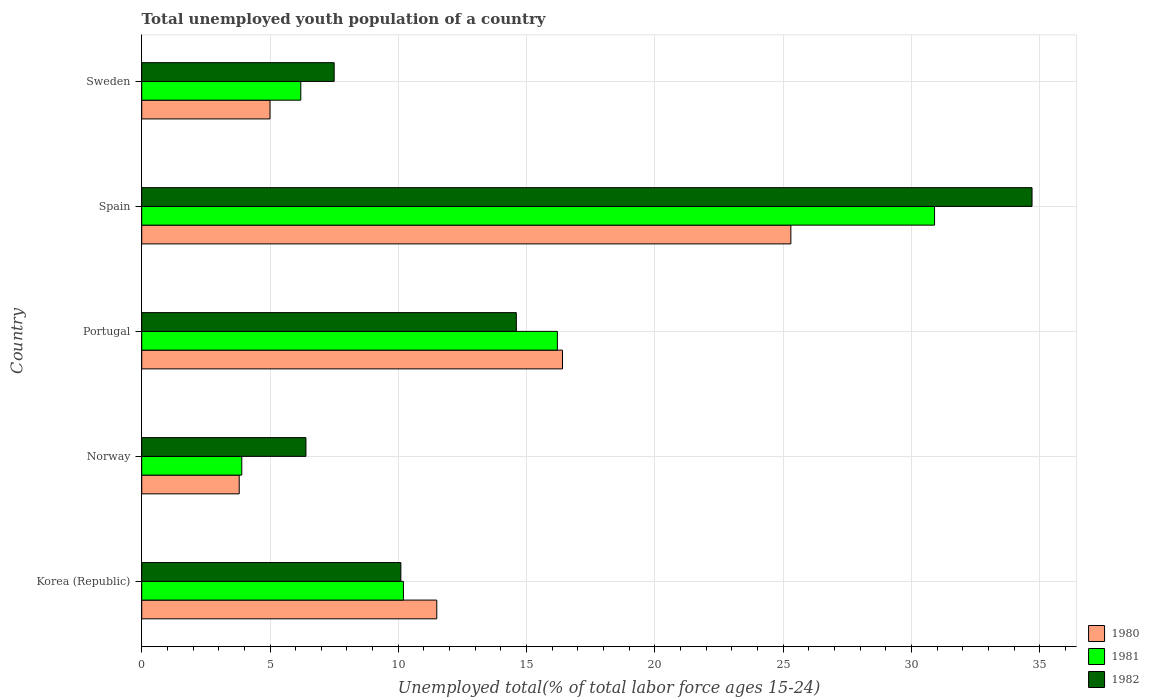How many different coloured bars are there?
Your answer should be compact. 3. Are the number of bars per tick equal to the number of legend labels?
Offer a very short reply. Yes. Are the number of bars on each tick of the Y-axis equal?
Your response must be concise. Yes. How many bars are there on the 5th tick from the top?
Your answer should be compact. 3. What is the label of the 5th group of bars from the top?
Provide a short and direct response. Korea (Republic). In how many cases, is the number of bars for a given country not equal to the number of legend labels?
Ensure brevity in your answer.  0. What is the percentage of total unemployed youth population of a country in 1980 in Norway?
Offer a terse response. 3.8. Across all countries, what is the maximum percentage of total unemployed youth population of a country in 1980?
Keep it short and to the point. 25.3. Across all countries, what is the minimum percentage of total unemployed youth population of a country in 1982?
Ensure brevity in your answer.  6.4. In which country was the percentage of total unemployed youth population of a country in 1980 maximum?
Keep it short and to the point. Spain. What is the total percentage of total unemployed youth population of a country in 1982 in the graph?
Keep it short and to the point. 73.3. What is the difference between the percentage of total unemployed youth population of a country in 1981 in Korea (Republic) and that in Sweden?
Your answer should be very brief. 4. What is the difference between the percentage of total unemployed youth population of a country in 1981 in Spain and the percentage of total unemployed youth population of a country in 1980 in Korea (Republic)?
Provide a succinct answer. 19.4. What is the average percentage of total unemployed youth population of a country in 1980 per country?
Offer a terse response. 12.4. What is the difference between the percentage of total unemployed youth population of a country in 1982 and percentage of total unemployed youth population of a country in 1981 in Spain?
Offer a very short reply. 3.8. In how many countries, is the percentage of total unemployed youth population of a country in 1981 greater than 23 %?
Keep it short and to the point. 1. What is the ratio of the percentage of total unemployed youth population of a country in 1980 in Norway to that in Sweden?
Provide a short and direct response. 0.76. Is the percentage of total unemployed youth population of a country in 1980 in Korea (Republic) less than that in Norway?
Your response must be concise. No. Is the difference between the percentage of total unemployed youth population of a country in 1982 in Portugal and Sweden greater than the difference between the percentage of total unemployed youth population of a country in 1981 in Portugal and Sweden?
Provide a short and direct response. No. What is the difference between the highest and the second highest percentage of total unemployed youth population of a country in 1981?
Your answer should be very brief. 14.7. What is the difference between the highest and the lowest percentage of total unemployed youth population of a country in 1981?
Provide a succinct answer. 27. In how many countries, is the percentage of total unemployed youth population of a country in 1982 greater than the average percentage of total unemployed youth population of a country in 1982 taken over all countries?
Provide a succinct answer. 1. Is the sum of the percentage of total unemployed youth population of a country in 1980 in Korea (Republic) and Spain greater than the maximum percentage of total unemployed youth population of a country in 1981 across all countries?
Offer a very short reply. Yes. What does the 2nd bar from the top in Sweden represents?
Offer a very short reply. 1981. What does the 1st bar from the bottom in Spain represents?
Provide a short and direct response. 1980. How many bars are there?
Your answer should be very brief. 15. Are all the bars in the graph horizontal?
Give a very brief answer. Yes. How many countries are there in the graph?
Offer a terse response. 5. What is the difference between two consecutive major ticks on the X-axis?
Your answer should be compact. 5. Does the graph contain any zero values?
Ensure brevity in your answer.  No. Does the graph contain grids?
Provide a short and direct response. Yes. Where does the legend appear in the graph?
Ensure brevity in your answer.  Bottom right. What is the title of the graph?
Offer a very short reply. Total unemployed youth population of a country. What is the label or title of the X-axis?
Your answer should be very brief. Unemployed total(% of total labor force ages 15-24). What is the label or title of the Y-axis?
Provide a short and direct response. Country. What is the Unemployed total(% of total labor force ages 15-24) of 1980 in Korea (Republic)?
Provide a short and direct response. 11.5. What is the Unemployed total(% of total labor force ages 15-24) in 1981 in Korea (Republic)?
Provide a short and direct response. 10.2. What is the Unemployed total(% of total labor force ages 15-24) in 1982 in Korea (Republic)?
Ensure brevity in your answer.  10.1. What is the Unemployed total(% of total labor force ages 15-24) in 1980 in Norway?
Offer a terse response. 3.8. What is the Unemployed total(% of total labor force ages 15-24) in 1981 in Norway?
Provide a succinct answer. 3.9. What is the Unemployed total(% of total labor force ages 15-24) of 1982 in Norway?
Provide a short and direct response. 6.4. What is the Unemployed total(% of total labor force ages 15-24) in 1980 in Portugal?
Make the answer very short. 16.4. What is the Unemployed total(% of total labor force ages 15-24) of 1981 in Portugal?
Ensure brevity in your answer.  16.2. What is the Unemployed total(% of total labor force ages 15-24) in 1982 in Portugal?
Your response must be concise. 14.6. What is the Unemployed total(% of total labor force ages 15-24) in 1980 in Spain?
Ensure brevity in your answer.  25.3. What is the Unemployed total(% of total labor force ages 15-24) in 1981 in Spain?
Keep it short and to the point. 30.9. What is the Unemployed total(% of total labor force ages 15-24) of 1982 in Spain?
Give a very brief answer. 34.7. What is the Unemployed total(% of total labor force ages 15-24) of 1981 in Sweden?
Give a very brief answer. 6.2. Across all countries, what is the maximum Unemployed total(% of total labor force ages 15-24) of 1980?
Ensure brevity in your answer.  25.3. Across all countries, what is the maximum Unemployed total(% of total labor force ages 15-24) of 1981?
Offer a very short reply. 30.9. Across all countries, what is the maximum Unemployed total(% of total labor force ages 15-24) of 1982?
Provide a succinct answer. 34.7. Across all countries, what is the minimum Unemployed total(% of total labor force ages 15-24) in 1980?
Give a very brief answer. 3.8. Across all countries, what is the minimum Unemployed total(% of total labor force ages 15-24) in 1981?
Your answer should be compact. 3.9. Across all countries, what is the minimum Unemployed total(% of total labor force ages 15-24) in 1982?
Your response must be concise. 6.4. What is the total Unemployed total(% of total labor force ages 15-24) in 1980 in the graph?
Your response must be concise. 62. What is the total Unemployed total(% of total labor force ages 15-24) of 1981 in the graph?
Offer a terse response. 67.4. What is the total Unemployed total(% of total labor force ages 15-24) of 1982 in the graph?
Offer a terse response. 73.3. What is the difference between the Unemployed total(% of total labor force ages 15-24) in 1982 in Korea (Republic) and that in Norway?
Offer a terse response. 3.7. What is the difference between the Unemployed total(% of total labor force ages 15-24) of 1980 in Korea (Republic) and that in Portugal?
Make the answer very short. -4.9. What is the difference between the Unemployed total(% of total labor force ages 15-24) of 1981 in Korea (Republic) and that in Spain?
Ensure brevity in your answer.  -20.7. What is the difference between the Unemployed total(% of total labor force ages 15-24) of 1982 in Korea (Republic) and that in Spain?
Provide a succinct answer. -24.6. What is the difference between the Unemployed total(% of total labor force ages 15-24) in 1981 in Korea (Republic) and that in Sweden?
Your answer should be very brief. 4. What is the difference between the Unemployed total(% of total labor force ages 15-24) of 1982 in Korea (Republic) and that in Sweden?
Make the answer very short. 2.6. What is the difference between the Unemployed total(% of total labor force ages 15-24) of 1980 in Norway and that in Portugal?
Your answer should be very brief. -12.6. What is the difference between the Unemployed total(% of total labor force ages 15-24) of 1981 in Norway and that in Portugal?
Ensure brevity in your answer.  -12.3. What is the difference between the Unemployed total(% of total labor force ages 15-24) in 1982 in Norway and that in Portugal?
Give a very brief answer. -8.2. What is the difference between the Unemployed total(% of total labor force ages 15-24) of 1980 in Norway and that in Spain?
Offer a terse response. -21.5. What is the difference between the Unemployed total(% of total labor force ages 15-24) in 1982 in Norway and that in Spain?
Keep it short and to the point. -28.3. What is the difference between the Unemployed total(% of total labor force ages 15-24) in 1980 in Norway and that in Sweden?
Your answer should be compact. -1.2. What is the difference between the Unemployed total(% of total labor force ages 15-24) in 1980 in Portugal and that in Spain?
Provide a short and direct response. -8.9. What is the difference between the Unemployed total(% of total labor force ages 15-24) of 1981 in Portugal and that in Spain?
Give a very brief answer. -14.7. What is the difference between the Unemployed total(% of total labor force ages 15-24) of 1982 in Portugal and that in Spain?
Keep it short and to the point. -20.1. What is the difference between the Unemployed total(% of total labor force ages 15-24) of 1980 in Portugal and that in Sweden?
Give a very brief answer. 11.4. What is the difference between the Unemployed total(% of total labor force ages 15-24) of 1982 in Portugal and that in Sweden?
Provide a succinct answer. 7.1. What is the difference between the Unemployed total(% of total labor force ages 15-24) in 1980 in Spain and that in Sweden?
Make the answer very short. 20.3. What is the difference between the Unemployed total(% of total labor force ages 15-24) in 1981 in Spain and that in Sweden?
Your answer should be very brief. 24.7. What is the difference between the Unemployed total(% of total labor force ages 15-24) in 1982 in Spain and that in Sweden?
Give a very brief answer. 27.2. What is the difference between the Unemployed total(% of total labor force ages 15-24) of 1980 in Korea (Republic) and the Unemployed total(% of total labor force ages 15-24) of 1981 in Norway?
Offer a terse response. 7.6. What is the difference between the Unemployed total(% of total labor force ages 15-24) of 1981 in Korea (Republic) and the Unemployed total(% of total labor force ages 15-24) of 1982 in Norway?
Offer a very short reply. 3.8. What is the difference between the Unemployed total(% of total labor force ages 15-24) in 1980 in Korea (Republic) and the Unemployed total(% of total labor force ages 15-24) in 1982 in Portugal?
Your answer should be compact. -3.1. What is the difference between the Unemployed total(% of total labor force ages 15-24) in 1980 in Korea (Republic) and the Unemployed total(% of total labor force ages 15-24) in 1981 in Spain?
Your response must be concise. -19.4. What is the difference between the Unemployed total(% of total labor force ages 15-24) in 1980 in Korea (Republic) and the Unemployed total(% of total labor force ages 15-24) in 1982 in Spain?
Give a very brief answer. -23.2. What is the difference between the Unemployed total(% of total labor force ages 15-24) in 1981 in Korea (Republic) and the Unemployed total(% of total labor force ages 15-24) in 1982 in Spain?
Offer a very short reply. -24.5. What is the difference between the Unemployed total(% of total labor force ages 15-24) in 1980 in Korea (Republic) and the Unemployed total(% of total labor force ages 15-24) in 1982 in Sweden?
Ensure brevity in your answer.  4. What is the difference between the Unemployed total(% of total labor force ages 15-24) in 1980 in Norway and the Unemployed total(% of total labor force ages 15-24) in 1981 in Spain?
Offer a very short reply. -27.1. What is the difference between the Unemployed total(% of total labor force ages 15-24) in 1980 in Norway and the Unemployed total(% of total labor force ages 15-24) in 1982 in Spain?
Keep it short and to the point. -30.9. What is the difference between the Unemployed total(% of total labor force ages 15-24) in 1981 in Norway and the Unemployed total(% of total labor force ages 15-24) in 1982 in Spain?
Offer a very short reply. -30.8. What is the difference between the Unemployed total(% of total labor force ages 15-24) of 1980 in Norway and the Unemployed total(% of total labor force ages 15-24) of 1981 in Sweden?
Provide a succinct answer. -2.4. What is the difference between the Unemployed total(% of total labor force ages 15-24) in 1980 in Norway and the Unemployed total(% of total labor force ages 15-24) in 1982 in Sweden?
Give a very brief answer. -3.7. What is the difference between the Unemployed total(% of total labor force ages 15-24) in 1981 in Norway and the Unemployed total(% of total labor force ages 15-24) in 1982 in Sweden?
Make the answer very short. -3.6. What is the difference between the Unemployed total(% of total labor force ages 15-24) in 1980 in Portugal and the Unemployed total(% of total labor force ages 15-24) in 1982 in Spain?
Offer a very short reply. -18.3. What is the difference between the Unemployed total(% of total labor force ages 15-24) of 1981 in Portugal and the Unemployed total(% of total labor force ages 15-24) of 1982 in Spain?
Your answer should be very brief. -18.5. What is the difference between the Unemployed total(% of total labor force ages 15-24) of 1980 in Portugal and the Unemployed total(% of total labor force ages 15-24) of 1981 in Sweden?
Offer a very short reply. 10.2. What is the difference between the Unemployed total(% of total labor force ages 15-24) of 1980 in Spain and the Unemployed total(% of total labor force ages 15-24) of 1982 in Sweden?
Provide a succinct answer. 17.8. What is the difference between the Unemployed total(% of total labor force ages 15-24) of 1981 in Spain and the Unemployed total(% of total labor force ages 15-24) of 1982 in Sweden?
Your answer should be very brief. 23.4. What is the average Unemployed total(% of total labor force ages 15-24) of 1981 per country?
Your answer should be very brief. 13.48. What is the average Unemployed total(% of total labor force ages 15-24) of 1982 per country?
Offer a terse response. 14.66. What is the difference between the Unemployed total(% of total labor force ages 15-24) in 1980 and Unemployed total(% of total labor force ages 15-24) in 1981 in Korea (Republic)?
Provide a succinct answer. 1.3. What is the difference between the Unemployed total(% of total labor force ages 15-24) of 1980 and Unemployed total(% of total labor force ages 15-24) of 1982 in Norway?
Provide a succinct answer. -2.6. What is the difference between the Unemployed total(% of total labor force ages 15-24) of 1981 and Unemployed total(% of total labor force ages 15-24) of 1982 in Norway?
Keep it short and to the point. -2.5. What is the difference between the Unemployed total(% of total labor force ages 15-24) of 1980 and Unemployed total(% of total labor force ages 15-24) of 1982 in Portugal?
Provide a succinct answer. 1.8. What is the difference between the Unemployed total(% of total labor force ages 15-24) in 1980 and Unemployed total(% of total labor force ages 15-24) in 1981 in Spain?
Offer a very short reply. -5.6. What is the difference between the Unemployed total(% of total labor force ages 15-24) of 1980 and Unemployed total(% of total labor force ages 15-24) of 1982 in Spain?
Provide a short and direct response. -9.4. What is the difference between the Unemployed total(% of total labor force ages 15-24) in 1981 and Unemployed total(% of total labor force ages 15-24) in 1982 in Spain?
Your answer should be compact. -3.8. What is the difference between the Unemployed total(% of total labor force ages 15-24) in 1980 and Unemployed total(% of total labor force ages 15-24) in 1981 in Sweden?
Ensure brevity in your answer.  -1.2. What is the difference between the Unemployed total(% of total labor force ages 15-24) in 1980 and Unemployed total(% of total labor force ages 15-24) in 1982 in Sweden?
Offer a terse response. -2.5. What is the ratio of the Unemployed total(% of total labor force ages 15-24) in 1980 in Korea (Republic) to that in Norway?
Your answer should be very brief. 3.03. What is the ratio of the Unemployed total(% of total labor force ages 15-24) in 1981 in Korea (Republic) to that in Norway?
Offer a terse response. 2.62. What is the ratio of the Unemployed total(% of total labor force ages 15-24) in 1982 in Korea (Republic) to that in Norway?
Your answer should be compact. 1.58. What is the ratio of the Unemployed total(% of total labor force ages 15-24) of 1980 in Korea (Republic) to that in Portugal?
Offer a very short reply. 0.7. What is the ratio of the Unemployed total(% of total labor force ages 15-24) in 1981 in Korea (Republic) to that in Portugal?
Give a very brief answer. 0.63. What is the ratio of the Unemployed total(% of total labor force ages 15-24) in 1982 in Korea (Republic) to that in Portugal?
Your response must be concise. 0.69. What is the ratio of the Unemployed total(% of total labor force ages 15-24) in 1980 in Korea (Republic) to that in Spain?
Provide a short and direct response. 0.45. What is the ratio of the Unemployed total(% of total labor force ages 15-24) in 1981 in Korea (Republic) to that in Spain?
Provide a short and direct response. 0.33. What is the ratio of the Unemployed total(% of total labor force ages 15-24) in 1982 in Korea (Republic) to that in Spain?
Keep it short and to the point. 0.29. What is the ratio of the Unemployed total(% of total labor force ages 15-24) of 1981 in Korea (Republic) to that in Sweden?
Your answer should be compact. 1.65. What is the ratio of the Unemployed total(% of total labor force ages 15-24) of 1982 in Korea (Republic) to that in Sweden?
Provide a succinct answer. 1.35. What is the ratio of the Unemployed total(% of total labor force ages 15-24) in 1980 in Norway to that in Portugal?
Your answer should be very brief. 0.23. What is the ratio of the Unemployed total(% of total labor force ages 15-24) in 1981 in Norway to that in Portugal?
Keep it short and to the point. 0.24. What is the ratio of the Unemployed total(% of total labor force ages 15-24) of 1982 in Norway to that in Portugal?
Provide a succinct answer. 0.44. What is the ratio of the Unemployed total(% of total labor force ages 15-24) of 1980 in Norway to that in Spain?
Offer a very short reply. 0.15. What is the ratio of the Unemployed total(% of total labor force ages 15-24) in 1981 in Norway to that in Spain?
Your answer should be compact. 0.13. What is the ratio of the Unemployed total(% of total labor force ages 15-24) of 1982 in Norway to that in Spain?
Give a very brief answer. 0.18. What is the ratio of the Unemployed total(% of total labor force ages 15-24) in 1980 in Norway to that in Sweden?
Your answer should be very brief. 0.76. What is the ratio of the Unemployed total(% of total labor force ages 15-24) in 1981 in Norway to that in Sweden?
Your response must be concise. 0.63. What is the ratio of the Unemployed total(% of total labor force ages 15-24) in 1982 in Norway to that in Sweden?
Make the answer very short. 0.85. What is the ratio of the Unemployed total(% of total labor force ages 15-24) in 1980 in Portugal to that in Spain?
Provide a succinct answer. 0.65. What is the ratio of the Unemployed total(% of total labor force ages 15-24) in 1981 in Portugal to that in Spain?
Offer a very short reply. 0.52. What is the ratio of the Unemployed total(% of total labor force ages 15-24) in 1982 in Portugal to that in Spain?
Keep it short and to the point. 0.42. What is the ratio of the Unemployed total(% of total labor force ages 15-24) of 1980 in Portugal to that in Sweden?
Offer a terse response. 3.28. What is the ratio of the Unemployed total(% of total labor force ages 15-24) of 1981 in Portugal to that in Sweden?
Provide a succinct answer. 2.61. What is the ratio of the Unemployed total(% of total labor force ages 15-24) in 1982 in Portugal to that in Sweden?
Your answer should be compact. 1.95. What is the ratio of the Unemployed total(% of total labor force ages 15-24) in 1980 in Spain to that in Sweden?
Ensure brevity in your answer.  5.06. What is the ratio of the Unemployed total(% of total labor force ages 15-24) of 1981 in Spain to that in Sweden?
Offer a terse response. 4.98. What is the ratio of the Unemployed total(% of total labor force ages 15-24) of 1982 in Spain to that in Sweden?
Keep it short and to the point. 4.63. What is the difference between the highest and the second highest Unemployed total(% of total labor force ages 15-24) of 1980?
Your answer should be very brief. 8.9. What is the difference between the highest and the second highest Unemployed total(% of total labor force ages 15-24) in 1981?
Your response must be concise. 14.7. What is the difference between the highest and the second highest Unemployed total(% of total labor force ages 15-24) in 1982?
Keep it short and to the point. 20.1. What is the difference between the highest and the lowest Unemployed total(% of total labor force ages 15-24) in 1982?
Your answer should be compact. 28.3. 